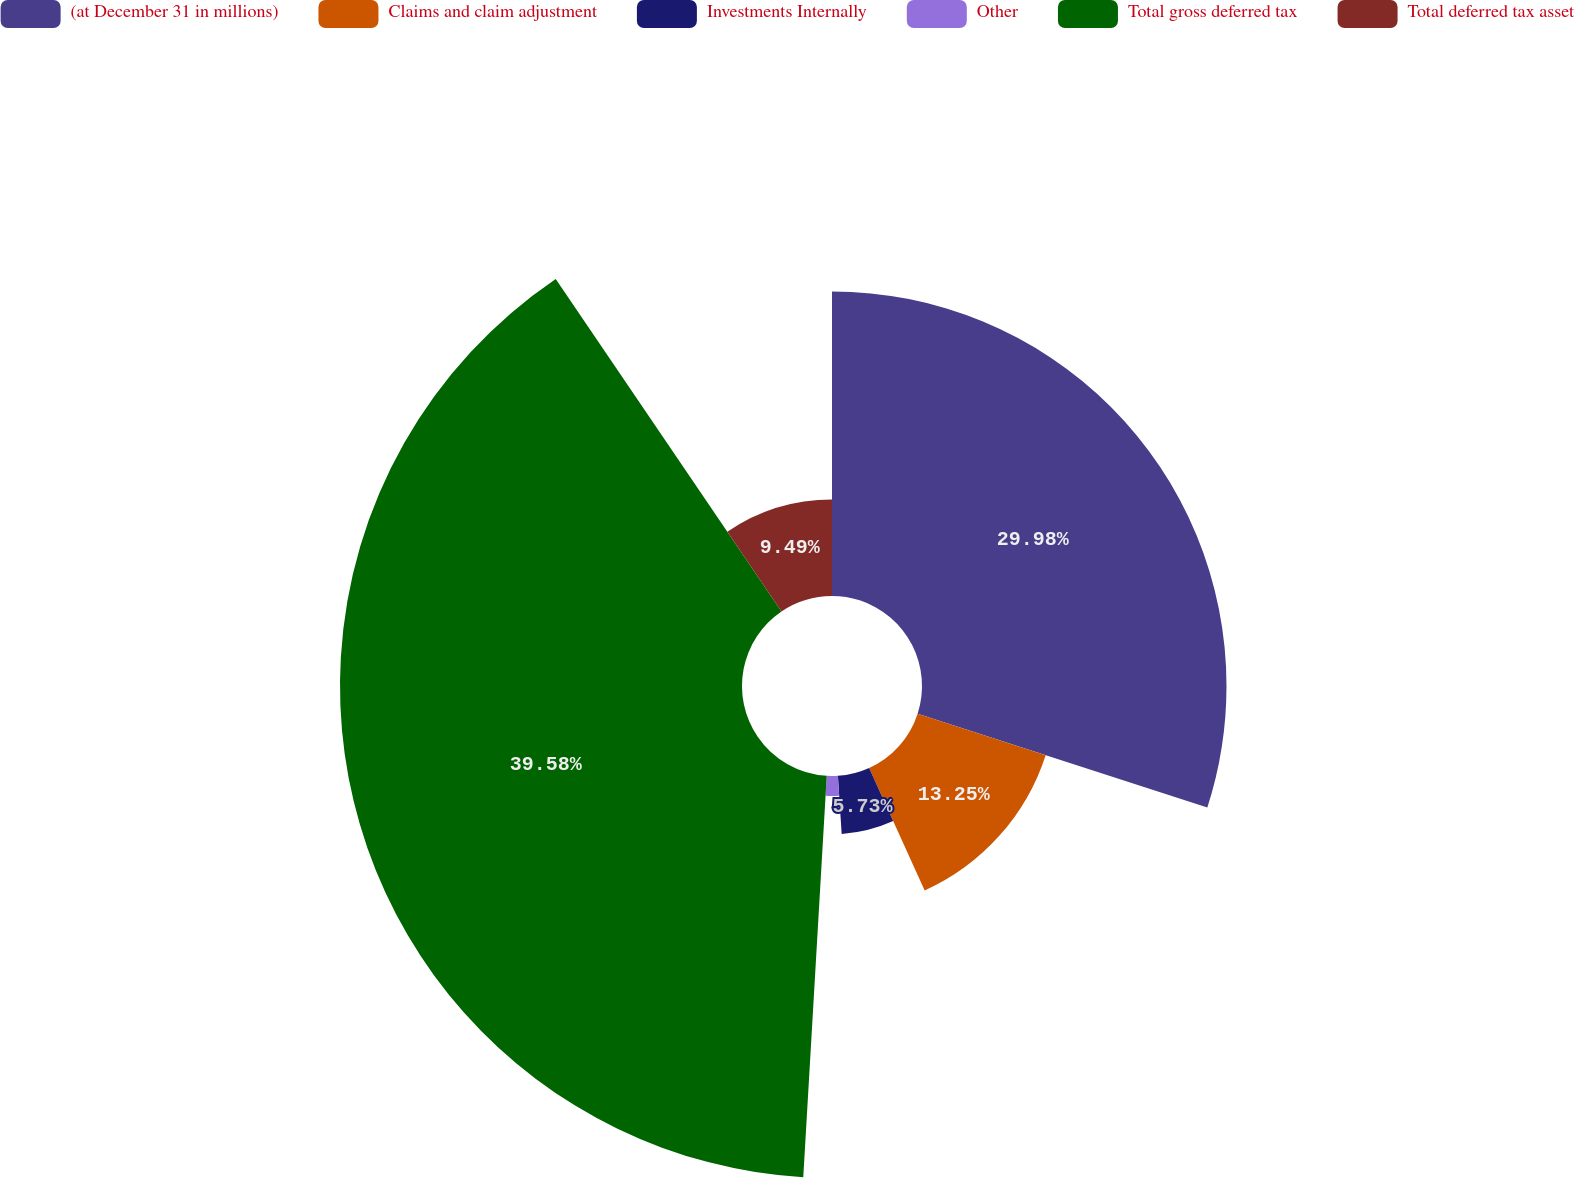Convert chart. <chart><loc_0><loc_0><loc_500><loc_500><pie_chart><fcel>(at December 31 in millions)<fcel>Claims and claim adjustment<fcel>Investments Internally<fcel>Other<fcel>Total gross deferred tax<fcel>Total deferred tax asset<nl><fcel>29.98%<fcel>13.25%<fcel>5.73%<fcel>1.97%<fcel>39.58%<fcel>9.49%<nl></chart> 